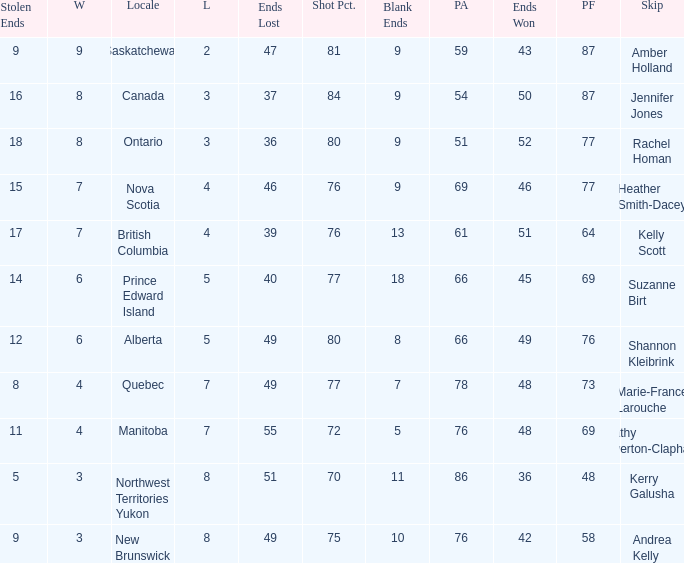If the skip is Kelly Scott, what is the PF total number? 1.0. 